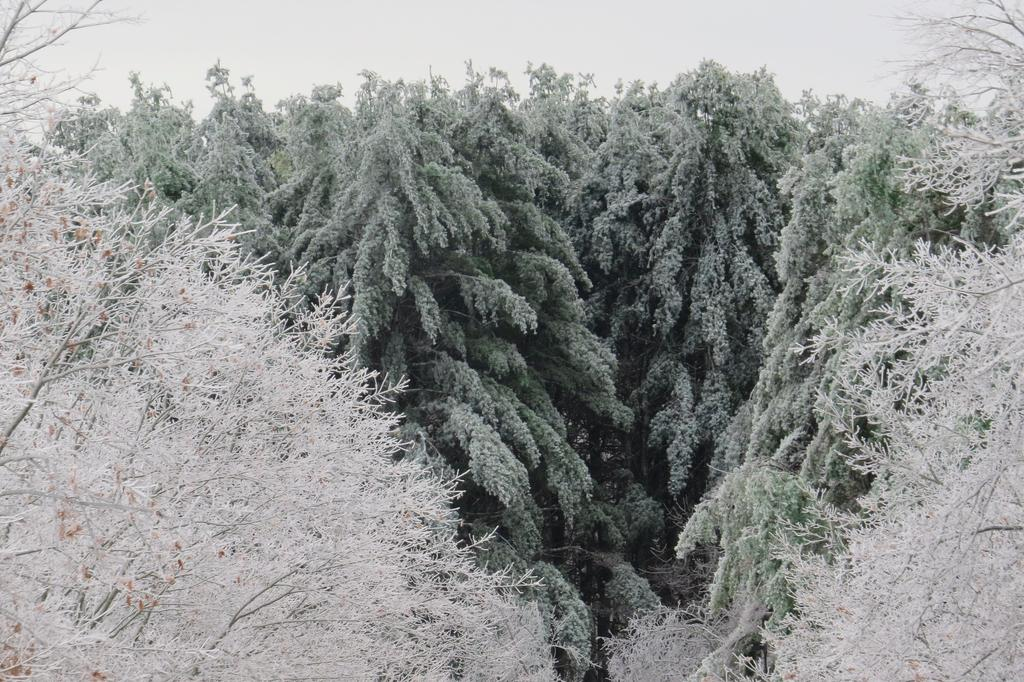What type of vegetation can be seen in the image? There are trees in the image. What is the color of the trees in the foreground? The trees in the foreground are white in color. What other type of vegetation is visible in the background? There are green trees in the background of the image. What else can be seen in the image besides the trees? The sky is visible in the image. How many sacks can be seen hanging from the trees in the image? There are no sacks present in the image; it features white trees and green trees in the background. 